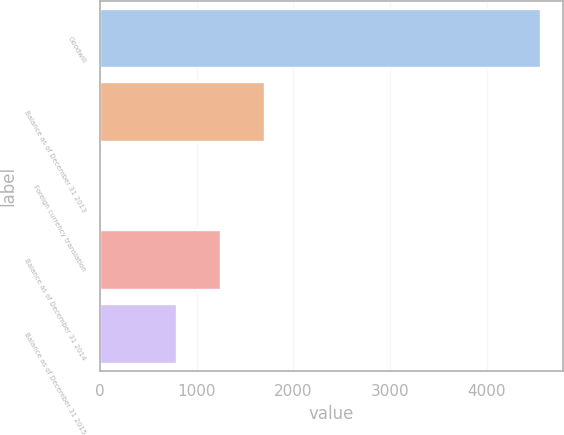<chart> <loc_0><loc_0><loc_500><loc_500><bar_chart><fcel>Goodwill<fcel>Balance as of December 31 2013<fcel>Foreign currency translation<fcel>Balance as of December 31 2014<fcel>Balance as of December 31 2015<nl><fcel>4563<fcel>1710.4<fcel>11<fcel>1255.2<fcel>800<nl></chart> 